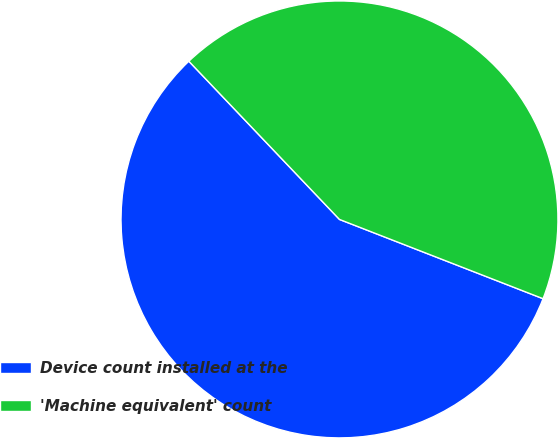Convert chart. <chart><loc_0><loc_0><loc_500><loc_500><pie_chart><fcel>Device count installed at the<fcel>'Machine equivalent' count<nl><fcel>56.98%<fcel>43.02%<nl></chart> 